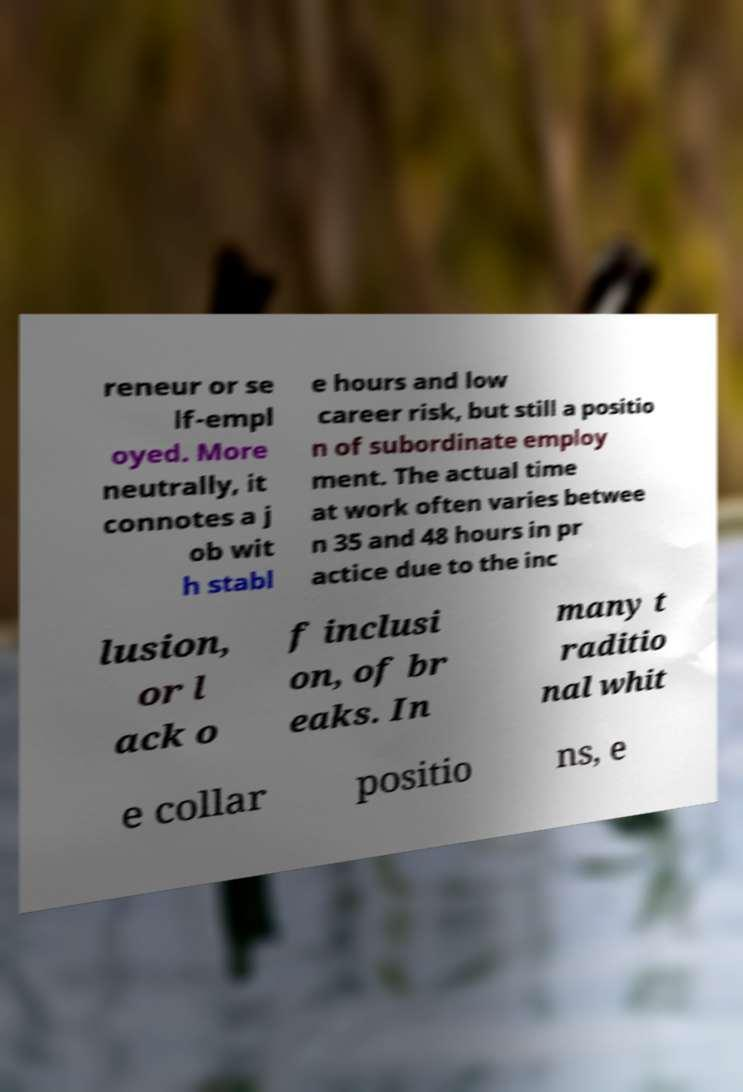Please identify and transcribe the text found in this image. reneur or se lf-empl oyed. More neutrally, it connotes a j ob wit h stabl e hours and low career risk, but still a positio n of subordinate employ ment. The actual time at work often varies betwee n 35 and 48 hours in pr actice due to the inc lusion, or l ack o f inclusi on, of br eaks. In many t raditio nal whit e collar positio ns, e 